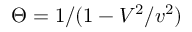Convert formula to latex. <formula><loc_0><loc_0><loc_500><loc_500>\Theta = 1 / ( 1 - V ^ { 2 } / v ^ { 2 } )</formula> 